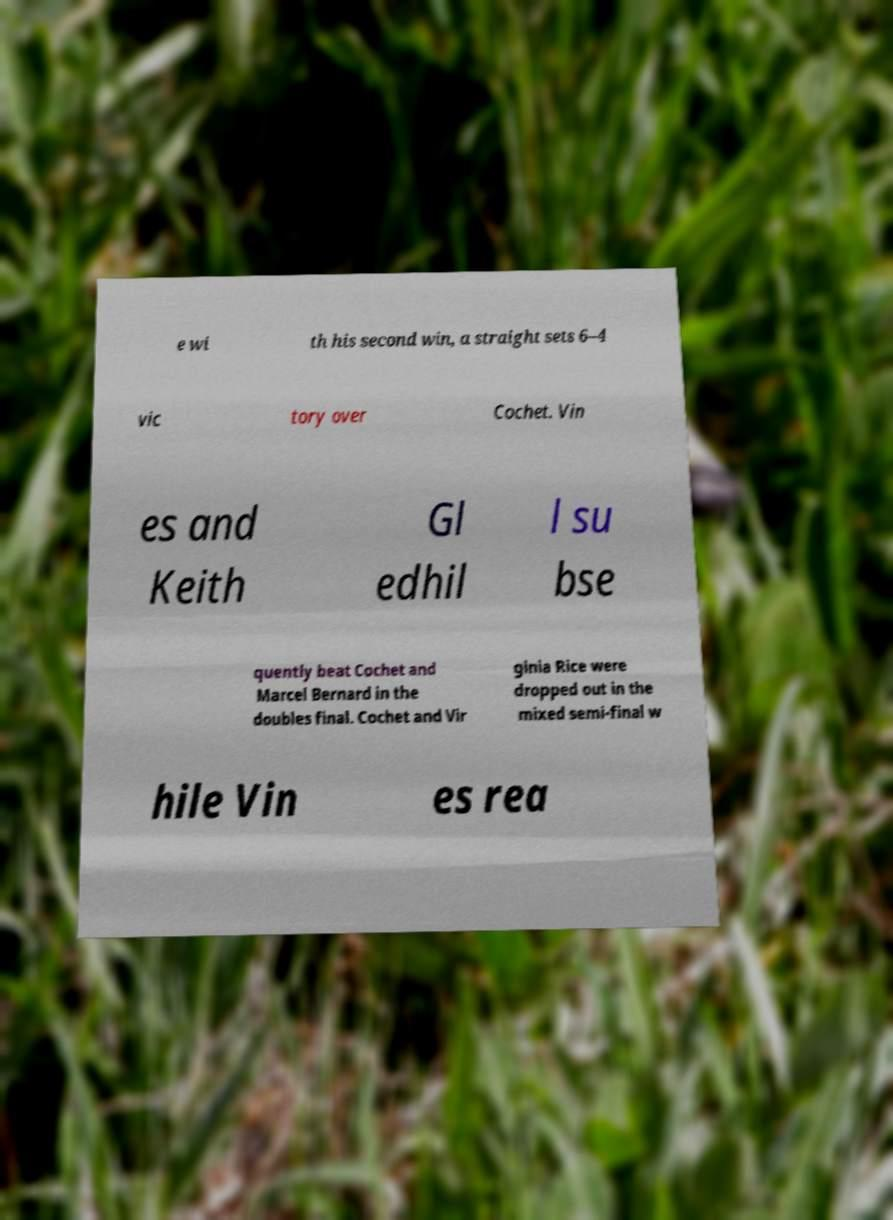Please identify and transcribe the text found in this image. e wi th his second win, a straight sets 6–4 vic tory over Cochet. Vin es and Keith Gl edhil l su bse quently beat Cochet and Marcel Bernard in the doubles final. Cochet and Vir ginia Rice were dropped out in the mixed semi-final w hile Vin es rea 